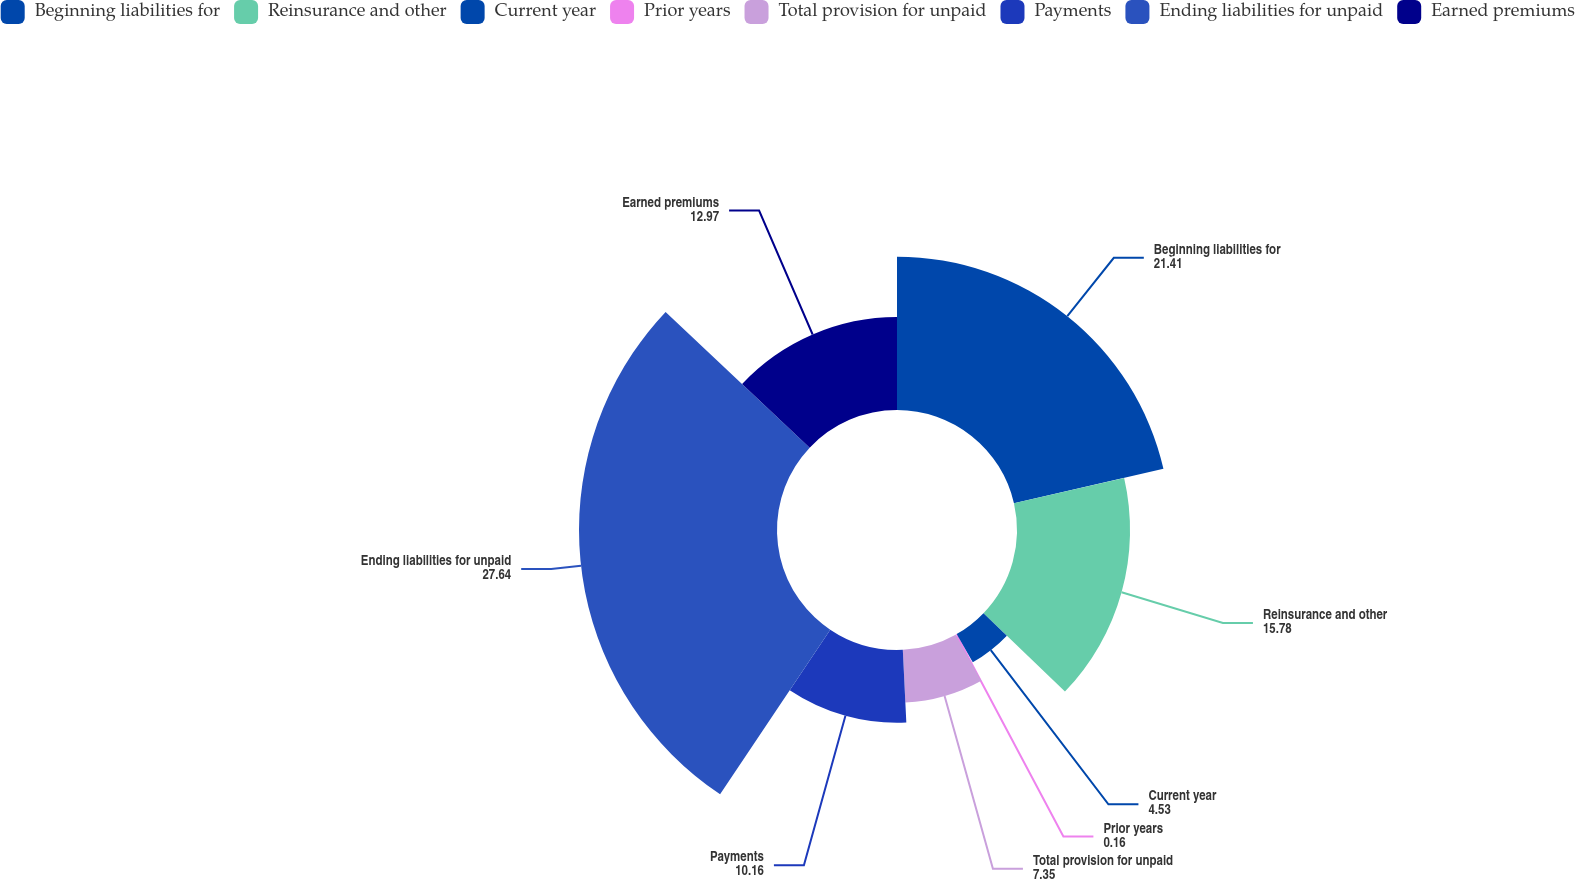Convert chart to OTSL. <chart><loc_0><loc_0><loc_500><loc_500><pie_chart><fcel>Beginning liabilities for<fcel>Reinsurance and other<fcel>Current year<fcel>Prior years<fcel>Total provision for unpaid<fcel>Payments<fcel>Ending liabilities for unpaid<fcel>Earned premiums<nl><fcel>21.41%<fcel>15.78%<fcel>4.53%<fcel>0.16%<fcel>7.35%<fcel>10.16%<fcel>27.64%<fcel>12.97%<nl></chart> 